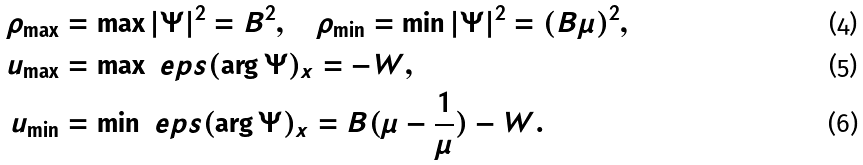<formula> <loc_0><loc_0><loc_500><loc_500>\rho _ { \max } & = \max | \Psi | ^ { 2 } = B ^ { 2 } , \quad \rho _ { \min } = \min | \Psi | ^ { 2 } = ( B \mu ) ^ { 2 } , \\ u _ { \max } & = \max \ e p s ( \arg \Psi ) _ { x } = - W , \\ u _ { \min } & = \min \ e p s ( \arg \Psi ) _ { x } = B ( \mu - \frac { 1 } { \mu } ) - W .</formula> 